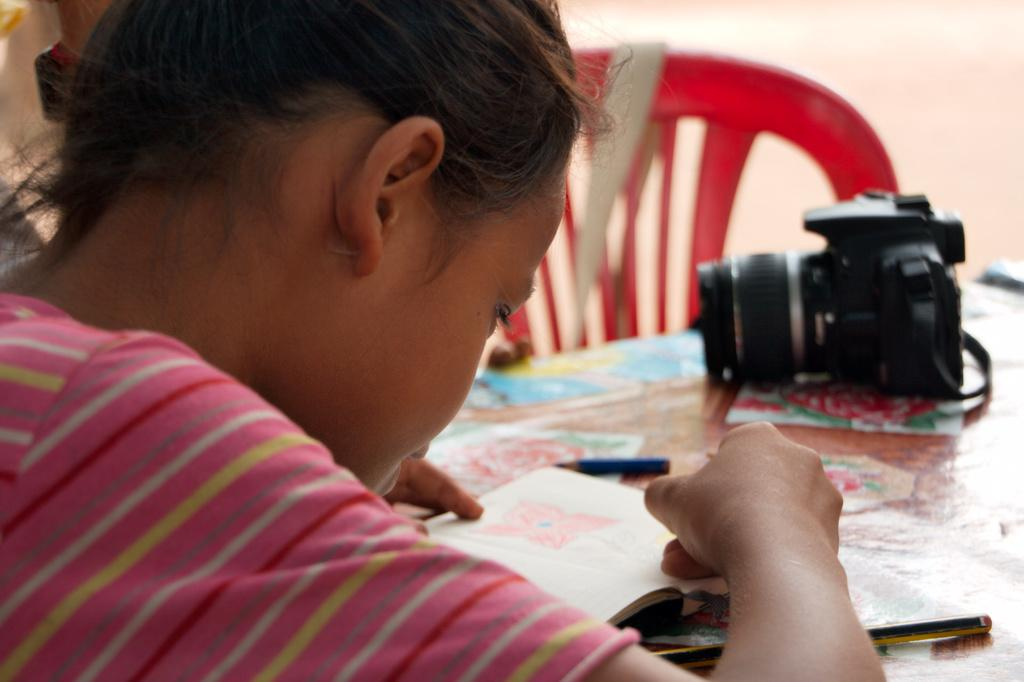Who is the main subject in the image? There is a girl in the image. What is the girl doing in the image? The girl is looking at a book in the image. Where is the book located? The book is on a table in the image. What other objects are on the table? There is a camera and pencils on the table in the image. What piece of furniture is in the image? There is a chair in the image. What can be seen in the background of the image? There is a wall in the image. How many cows are visible in the image? There are no cows present in the image. What type of milk is the girl drinking from the book? The girl is not drinking milk from the book; she is looking at it. 